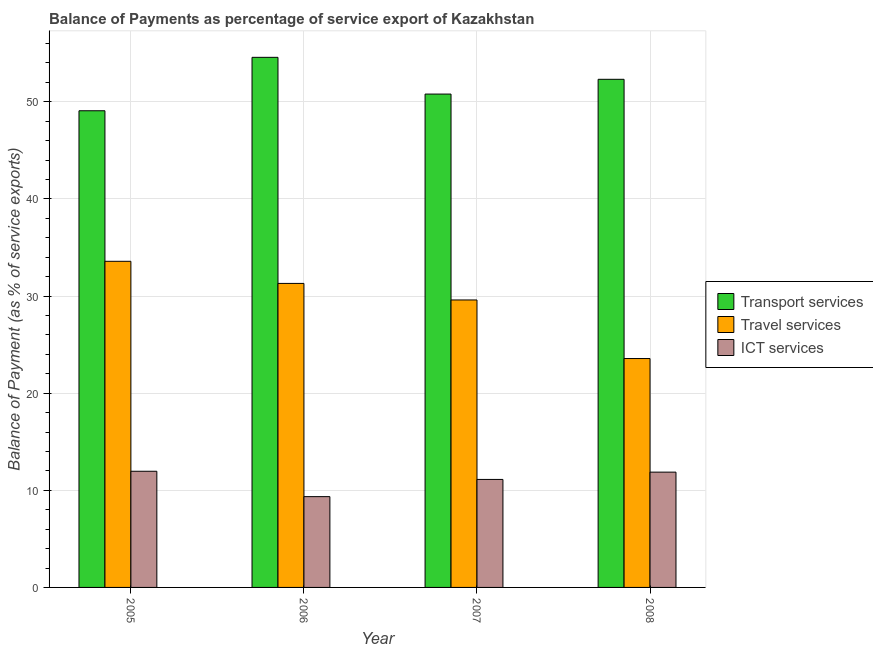Are the number of bars per tick equal to the number of legend labels?
Your answer should be very brief. Yes. Are the number of bars on each tick of the X-axis equal?
Ensure brevity in your answer.  Yes. In how many cases, is the number of bars for a given year not equal to the number of legend labels?
Your answer should be very brief. 0. What is the balance of payment of ict services in 2008?
Ensure brevity in your answer.  11.87. Across all years, what is the maximum balance of payment of travel services?
Your answer should be compact. 33.58. Across all years, what is the minimum balance of payment of travel services?
Your response must be concise. 23.57. What is the total balance of payment of ict services in the graph?
Provide a short and direct response. 44.3. What is the difference between the balance of payment of travel services in 2005 and that in 2008?
Your response must be concise. 10.01. What is the difference between the balance of payment of ict services in 2007 and the balance of payment of transport services in 2008?
Your answer should be very brief. -0.75. What is the average balance of payment of travel services per year?
Make the answer very short. 29.51. In how many years, is the balance of payment of ict services greater than 52 %?
Offer a terse response. 0. What is the ratio of the balance of payment of ict services in 2006 to that in 2007?
Ensure brevity in your answer.  0.84. What is the difference between the highest and the second highest balance of payment of transport services?
Offer a terse response. 2.26. What is the difference between the highest and the lowest balance of payment of ict services?
Offer a very short reply. 2.61. Is the sum of the balance of payment of travel services in 2005 and 2008 greater than the maximum balance of payment of ict services across all years?
Your response must be concise. Yes. What does the 3rd bar from the left in 2006 represents?
Ensure brevity in your answer.  ICT services. What does the 2nd bar from the right in 2007 represents?
Make the answer very short. Travel services. How many bars are there?
Offer a terse response. 12. Are all the bars in the graph horizontal?
Give a very brief answer. No. How many years are there in the graph?
Provide a succinct answer. 4. What is the difference between two consecutive major ticks on the Y-axis?
Provide a succinct answer. 10. Are the values on the major ticks of Y-axis written in scientific E-notation?
Make the answer very short. No. Does the graph contain any zero values?
Offer a terse response. No. Does the graph contain grids?
Make the answer very short. Yes. What is the title of the graph?
Your answer should be very brief. Balance of Payments as percentage of service export of Kazakhstan. What is the label or title of the X-axis?
Make the answer very short. Year. What is the label or title of the Y-axis?
Make the answer very short. Balance of Payment (as % of service exports). What is the Balance of Payment (as % of service exports) of Transport services in 2005?
Your answer should be compact. 49.08. What is the Balance of Payment (as % of service exports) in Travel services in 2005?
Offer a terse response. 33.58. What is the Balance of Payment (as % of service exports) in ICT services in 2005?
Give a very brief answer. 11.96. What is the Balance of Payment (as % of service exports) of Transport services in 2006?
Keep it short and to the point. 54.58. What is the Balance of Payment (as % of service exports) in Travel services in 2006?
Give a very brief answer. 31.3. What is the Balance of Payment (as % of service exports) of ICT services in 2006?
Ensure brevity in your answer.  9.35. What is the Balance of Payment (as % of service exports) in Transport services in 2007?
Make the answer very short. 50.8. What is the Balance of Payment (as % of service exports) in Travel services in 2007?
Provide a succinct answer. 29.6. What is the Balance of Payment (as % of service exports) in ICT services in 2007?
Offer a very short reply. 11.12. What is the Balance of Payment (as % of service exports) of Transport services in 2008?
Ensure brevity in your answer.  52.32. What is the Balance of Payment (as % of service exports) of Travel services in 2008?
Offer a very short reply. 23.57. What is the Balance of Payment (as % of service exports) in ICT services in 2008?
Provide a succinct answer. 11.87. Across all years, what is the maximum Balance of Payment (as % of service exports) in Transport services?
Keep it short and to the point. 54.58. Across all years, what is the maximum Balance of Payment (as % of service exports) in Travel services?
Keep it short and to the point. 33.58. Across all years, what is the maximum Balance of Payment (as % of service exports) in ICT services?
Give a very brief answer. 11.96. Across all years, what is the minimum Balance of Payment (as % of service exports) of Transport services?
Your answer should be compact. 49.08. Across all years, what is the minimum Balance of Payment (as % of service exports) of Travel services?
Make the answer very short. 23.57. Across all years, what is the minimum Balance of Payment (as % of service exports) of ICT services?
Provide a succinct answer. 9.35. What is the total Balance of Payment (as % of service exports) of Transport services in the graph?
Your answer should be compact. 206.77. What is the total Balance of Payment (as % of service exports) in Travel services in the graph?
Ensure brevity in your answer.  118.04. What is the total Balance of Payment (as % of service exports) in ICT services in the graph?
Make the answer very short. 44.3. What is the difference between the Balance of Payment (as % of service exports) of Transport services in 2005 and that in 2006?
Provide a short and direct response. -5.5. What is the difference between the Balance of Payment (as % of service exports) of Travel services in 2005 and that in 2006?
Your response must be concise. 2.28. What is the difference between the Balance of Payment (as % of service exports) of ICT services in 2005 and that in 2006?
Give a very brief answer. 2.61. What is the difference between the Balance of Payment (as % of service exports) of Transport services in 2005 and that in 2007?
Your answer should be very brief. -1.72. What is the difference between the Balance of Payment (as % of service exports) of Travel services in 2005 and that in 2007?
Provide a succinct answer. 3.98. What is the difference between the Balance of Payment (as % of service exports) in ICT services in 2005 and that in 2007?
Your answer should be compact. 0.84. What is the difference between the Balance of Payment (as % of service exports) in Transport services in 2005 and that in 2008?
Give a very brief answer. -3.24. What is the difference between the Balance of Payment (as % of service exports) in Travel services in 2005 and that in 2008?
Ensure brevity in your answer.  10.01. What is the difference between the Balance of Payment (as % of service exports) of ICT services in 2005 and that in 2008?
Your answer should be very brief. 0.09. What is the difference between the Balance of Payment (as % of service exports) in Transport services in 2006 and that in 2007?
Provide a short and direct response. 3.78. What is the difference between the Balance of Payment (as % of service exports) in Travel services in 2006 and that in 2007?
Your answer should be compact. 1.7. What is the difference between the Balance of Payment (as % of service exports) of ICT services in 2006 and that in 2007?
Offer a very short reply. -1.77. What is the difference between the Balance of Payment (as % of service exports) of Transport services in 2006 and that in 2008?
Keep it short and to the point. 2.26. What is the difference between the Balance of Payment (as % of service exports) of Travel services in 2006 and that in 2008?
Offer a terse response. 7.73. What is the difference between the Balance of Payment (as % of service exports) of ICT services in 2006 and that in 2008?
Your answer should be compact. -2.52. What is the difference between the Balance of Payment (as % of service exports) in Transport services in 2007 and that in 2008?
Provide a short and direct response. -1.52. What is the difference between the Balance of Payment (as % of service exports) in Travel services in 2007 and that in 2008?
Ensure brevity in your answer.  6.03. What is the difference between the Balance of Payment (as % of service exports) in ICT services in 2007 and that in 2008?
Your answer should be compact. -0.75. What is the difference between the Balance of Payment (as % of service exports) of Transport services in 2005 and the Balance of Payment (as % of service exports) of Travel services in 2006?
Offer a terse response. 17.78. What is the difference between the Balance of Payment (as % of service exports) of Transport services in 2005 and the Balance of Payment (as % of service exports) of ICT services in 2006?
Provide a short and direct response. 39.73. What is the difference between the Balance of Payment (as % of service exports) in Travel services in 2005 and the Balance of Payment (as % of service exports) in ICT services in 2006?
Give a very brief answer. 24.23. What is the difference between the Balance of Payment (as % of service exports) of Transport services in 2005 and the Balance of Payment (as % of service exports) of Travel services in 2007?
Give a very brief answer. 19.48. What is the difference between the Balance of Payment (as % of service exports) of Transport services in 2005 and the Balance of Payment (as % of service exports) of ICT services in 2007?
Offer a terse response. 37.96. What is the difference between the Balance of Payment (as % of service exports) of Travel services in 2005 and the Balance of Payment (as % of service exports) of ICT services in 2007?
Your response must be concise. 22.46. What is the difference between the Balance of Payment (as % of service exports) in Transport services in 2005 and the Balance of Payment (as % of service exports) in Travel services in 2008?
Make the answer very short. 25.51. What is the difference between the Balance of Payment (as % of service exports) of Transport services in 2005 and the Balance of Payment (as % of service exports) of ICT services in 2008?
Give a very brief answer. 37.21. What is the difference between the Balance of Payment (as % of service exports) of Travel services in 2005 and the Balance of Payment (as % of service exports) of ICT services in 2008?
Your answer should be very brief. 21.71. What is the difference between the Balance of Payment (as % of service exports) in Transport services in 2006 and the Balance of Payment (as % of service exports) in Travel services in 2007?
Provide a short and direct response. 24.98. What is the difference between the Balance of Payment (as % of service exports) of Transport services in 2006 and the Balance of Payment (as % of service exports) of ICT services in 2007?
Give a very brief answer. 43.46. What is the difference between the Balance of Payment (as % of service exports) of Travel services in 2006 and the Balance of Payment (as % of service exports) of ICT services in 2007?
Your answer should be compact. 20.18. What is the difference between the Balance of Payment (as % of service exports) in Transport services in 2006 and the Balance of Payment (as % of service exports) in Travel services in 2008?
Ensure brevity in your answer.  31.01. What is the difference between the Balance of Payment (as % of service exports) of Transport services in 2006 and the Balance of Payment (as % of service exports) of ICT services in 2008?
Your response must be concise. 42.71. What is the difference between the Balance of Payment (as % of service exports) of Travel services in 2006 and the Balance of Payment (as % of service exports) of ICT services in 2008?
Give a very brief answer. 19.43. What is the difference between the Balance of Payment (as % of service exports) of Transport services in 2007 and the Balance of Payment (as % of service exports) of Travel services in 2008?
Your answer should be compact. 27.23. What is the difference between the Balance of Payment (as % of service exports) of Transport services in 2007 and the Balance of Payment (as % of service exports) of ICT services in 2008?
Your response must be concise. 38.93. What is the difference between the Balance of Payment (as % of service exports) in Travel services in 2007 and the Balance of Payment (as % of service exports) in ICT services in 2008?
Ensure brevity in your answer.  17.73. What is the average Balance of Payment (as % of service exports) of Transport services per year?
Your response must be concise. 51.69. What is the average Balance of Payment (as % of service exports) of Travel services per year?
Give a very brief answer. 29.51. What is the average Balance of Payment (as % of service exports) of ICT services per year?
Your answer should be very brief. 11.07. In the year 2005, what is the difference between the Balance of Payment (as % of service exports) of Transport services and Balance of Payment (as % of service exports) of Travel services?
Offer a terse response. 15.5. In the year 2005, what is the difference between the Balance of Payment (as % of service exports) of Transport services and Balance of Payment (as % of service exports) of ICT services?
Your answer should be compact. 37.12. In the year 2005, what is the difference between the Balance of Payment (as % of service exports) in Travel services and Balance of Payment (as % of service exports) in ICT services?
Offer a very short reply. 21.62. In the year 2006, what is the difference between the Balance of Payment (as % of service exports) in Transport services and Balance of Payment (as % of service exports) in Travel services?
Your answer should be compact. 23.28. In the year 2006, what is the difference between the Balance of Payment (as % of service exports) in Transport services and Balance of Payment (as % of service exports) in ICT services?
Your answer should be very brief. 45.23. In the year 2006, what is the difference between the Balance of Payment (as % of service exports) of Travel services and Balance of Payment (as % of service exports) of ICT services?
Your answer should be very brief. 21.95. In the year 2007, what is the difference between the Balance of Payment (as % of service exports) of Transport services and Balance of Payment (as % of service exports) of Travel services?
Give a very brief answer. 21.2. In the year 2007, what is the difference between the Balance of Payment (as % of service exports) in Transport services and Balance of Payment (as % of service exports) in ICT services?
Make the answer very short. 39.68. In the year 2007, what is the difference between the Balance of Payment (as % of service exports) in Travel services and Balance of Payment (as % of service exports) in ICT services?
Make the answer very short. 18.48. In the year 2008, what is the difference between the Balance of Payment (as % of service exports) of Transport services and Balance of Payment (as % of service exports) of Travel services?
Keep it short and to the point. 28.75. In the year 2008, what is the difference between the Balance of Payment (as % of service exports) in Transport services and Balance of Payment (as % of service exports) in ICT services?
Give a very brief answer. 40.45. In the year 2008, what is the difference between the Balance of Payment (as % of service exports) of Travel services and Balance of Payment (as % of service exports) of ICT services?
Ensure brevity in your answer.  11.7. What is the ratio of the Balance of Payment (as % of service exports) of Transport services in 2005 to that in 2006?
Your answer should be very brief. 0.9. What is the ratio of the Balance of Payment (as % of service exports) in Travel services in 2005 to that in 2006?
Give a very brief answer. 1.07. What is the ratio of the Balance of Payment (as % of service exports) in ICT services in 2005 to that in 2006?
Provide a short and direct response. 1.28. What is the ratio of the Balance of Payment (as % of service exports) in Transport services in 2005 to that in 2007?
Your response must be concise. 0.97. What is the ratio of the Balance of Payment (as % of service exports) of Travel services in 2005 to that in 2007?
Ensure brevity in your answer.  1.13. What is the ratio of the Balance of Payment (as % of service exports) in ICT services in 2005 to that in 2007?
Your answer should be compact. 1.08. What is the ratio of the Balance of Payment (as % of service exports) of Transport services in 2005 to that in 2008?
Provide a succinct answer. 0.94. What is the ratio of the Balance of Payment (as % of service exports) of Travel services in 2005 to that in 2008?
Give a very brief answer. 1.42. What is the ratio of the Balance of Payment (as % of service exports) in ICT services in 2005 to that in 2008?
Offer a very short reply. 1.01. What is the ratio of the Balance of Payment (as % of service exports) of Transport services in 2006 to that in 2007?
Offer a terse response. 1.07. What is the ratio of the Balance of Payment (as % of service exports) of Travel services in 2006 to that in 2007?
Your response must be concise. 1.06. What is the ratio of the Balance of Payment (as % of service exports) in ICT services in 2006 to that in 2007?
Your answer should be very brief. 0.84. What is the ratio of the Balance of Payment (as % of service exports) of Transport services in 2006 to that in 2008?
Your answer should be very brief. 1.04. What is the ratio of the Balance of Payment (as % of service exports) of Travel services in 2006 to that in 2008?
Make the answer very short. 1.33. What is the ratio of the Balance of Payment (as % of service exports) of ICT services in 2006 to that in 2008?
Offer a very short reply. 0.79. What is the ratio of the Balance of Payment (as % of service exports) of Transport services in 2007 to that in 2008?
Give a very brief answer. 0.97. What is the ratio of the Balance of Payment (as % of service exports) of Travel services in 2007 to that in 2008?
Your response must be concise. 1.26. What is the ratio of the Balance of Payment (as % of service exports) of ICT services in 2007 to that in 2008?
Your answer should be very brief. 0.94. What is the difference between the highest and the second highest Balance of Payment (as % of service exports) in Transport services?
Provide a short and direct response. 2.26. What is the difference between the highest and the second highest Balance of Payment (as % of service exports) of Travel services?
Provide a short and direct response. 2.28. What is the difference between the highest and the second highest Balance of Payment (as % of service exports) in ICT services?
Your answer should be very brief. 0.09. What is the difference between the highest and the lowest Balance of Payment (as % of service exports) in Transport services?
Make the answer very short. 5.5. What is the difference between the highest and the lowest Balance of Payment (as % of service exports) in Travel services?
Keep it short and to the point. 10.01. What is the difference between the highest and the lowest Balance of Payment (as % of service exports) in ICT services?
Your response must be concise. 2.61. 